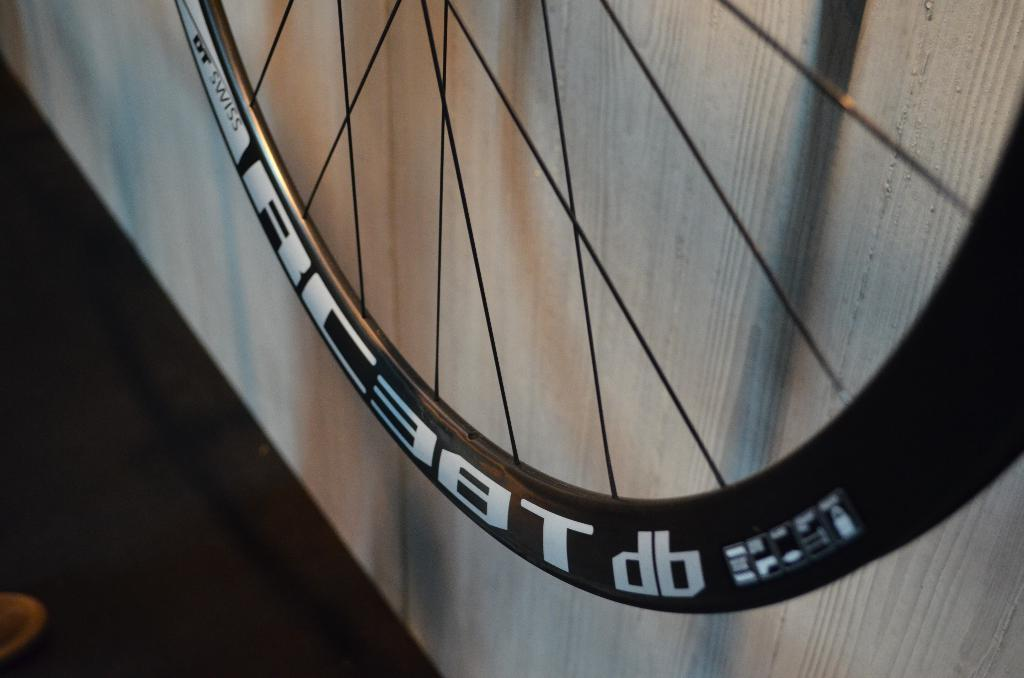What is the main object in the image? There is a wheel in the image. Can you describe the wheel's position or placement? The wheel is placed on a surface. What type of cable is connected to the wheel in the image? There is no cable connected to the wheel in the image. Can you describe the rat that is sitting on the wheel in the image? There is no rat present in the image; only the wheel is visible. 